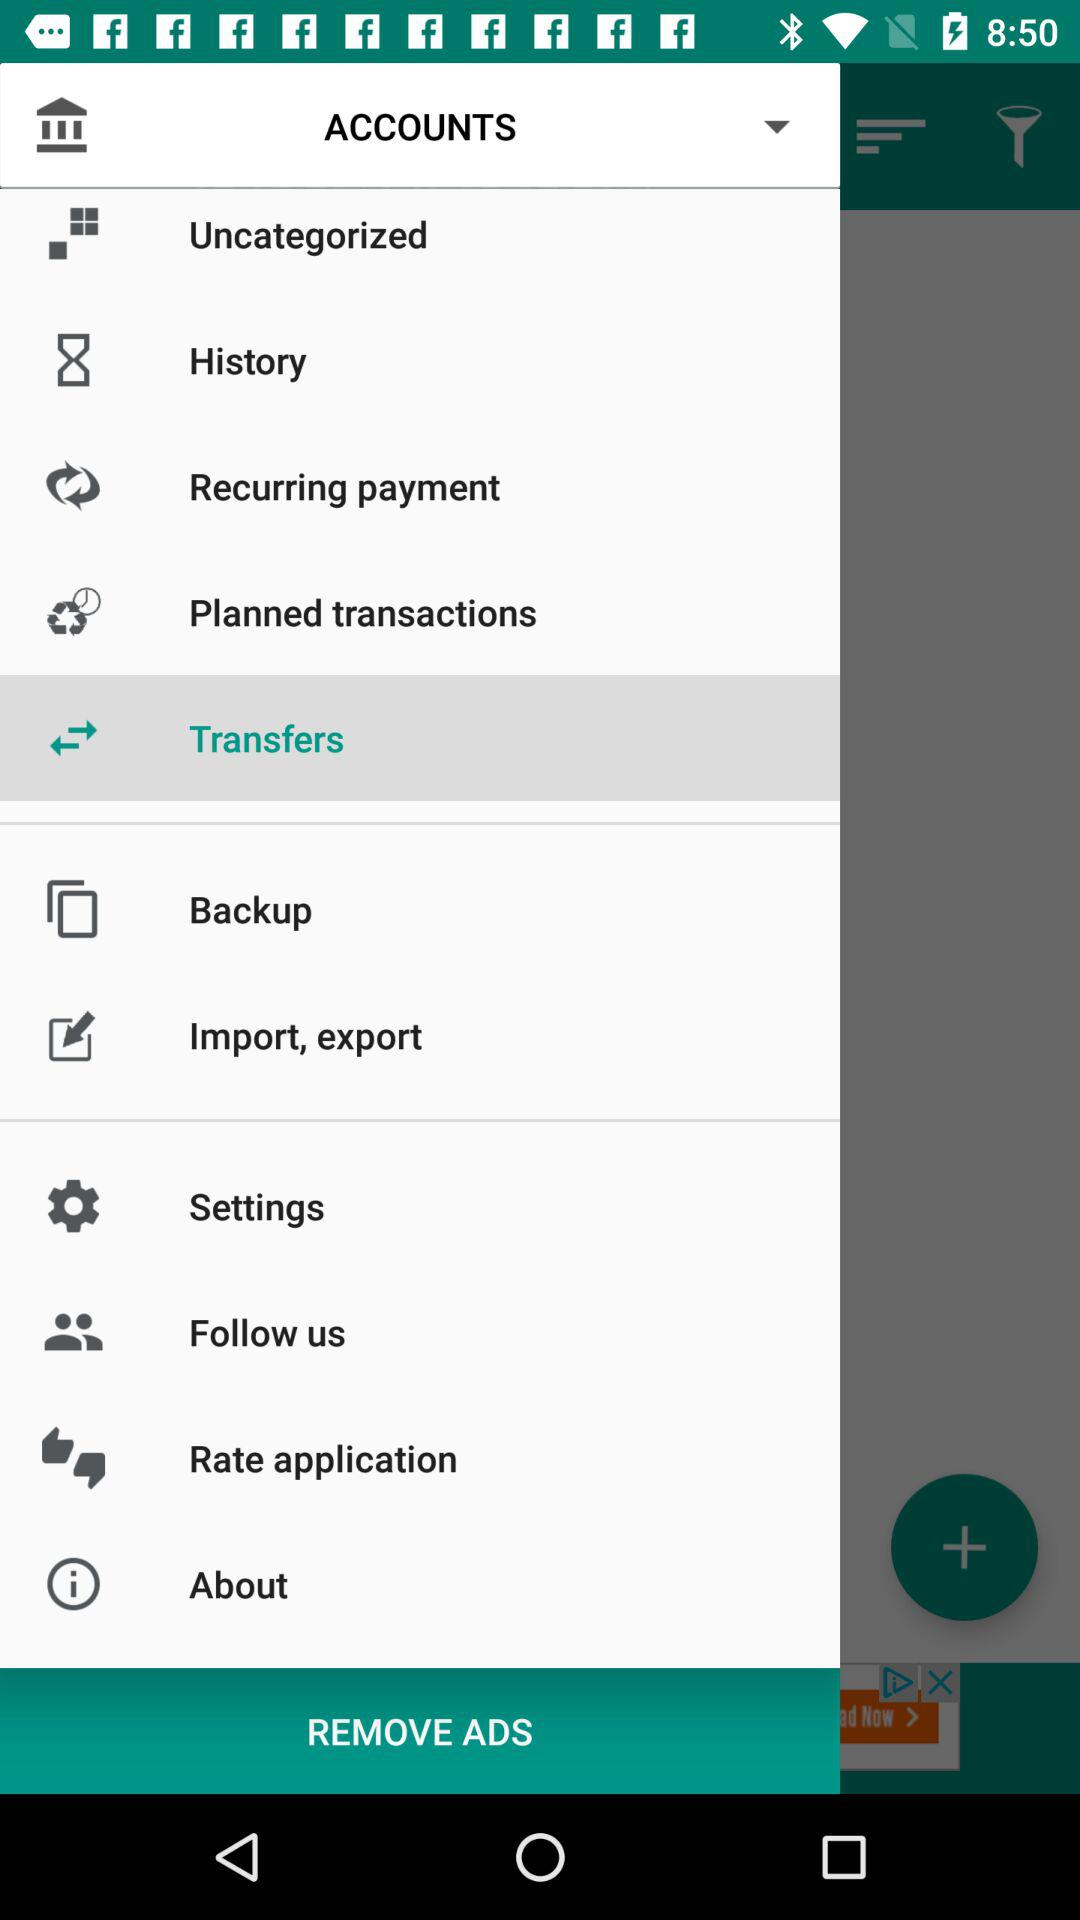Which item is selected? The selected item is "Transfers". 